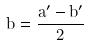Convert formula to latex. <formula><loc_0><loc_0><loc_500><loc_500>b = \frac { a ^ { \prime } - b ^ { \prime } } { 2 }</formula> 